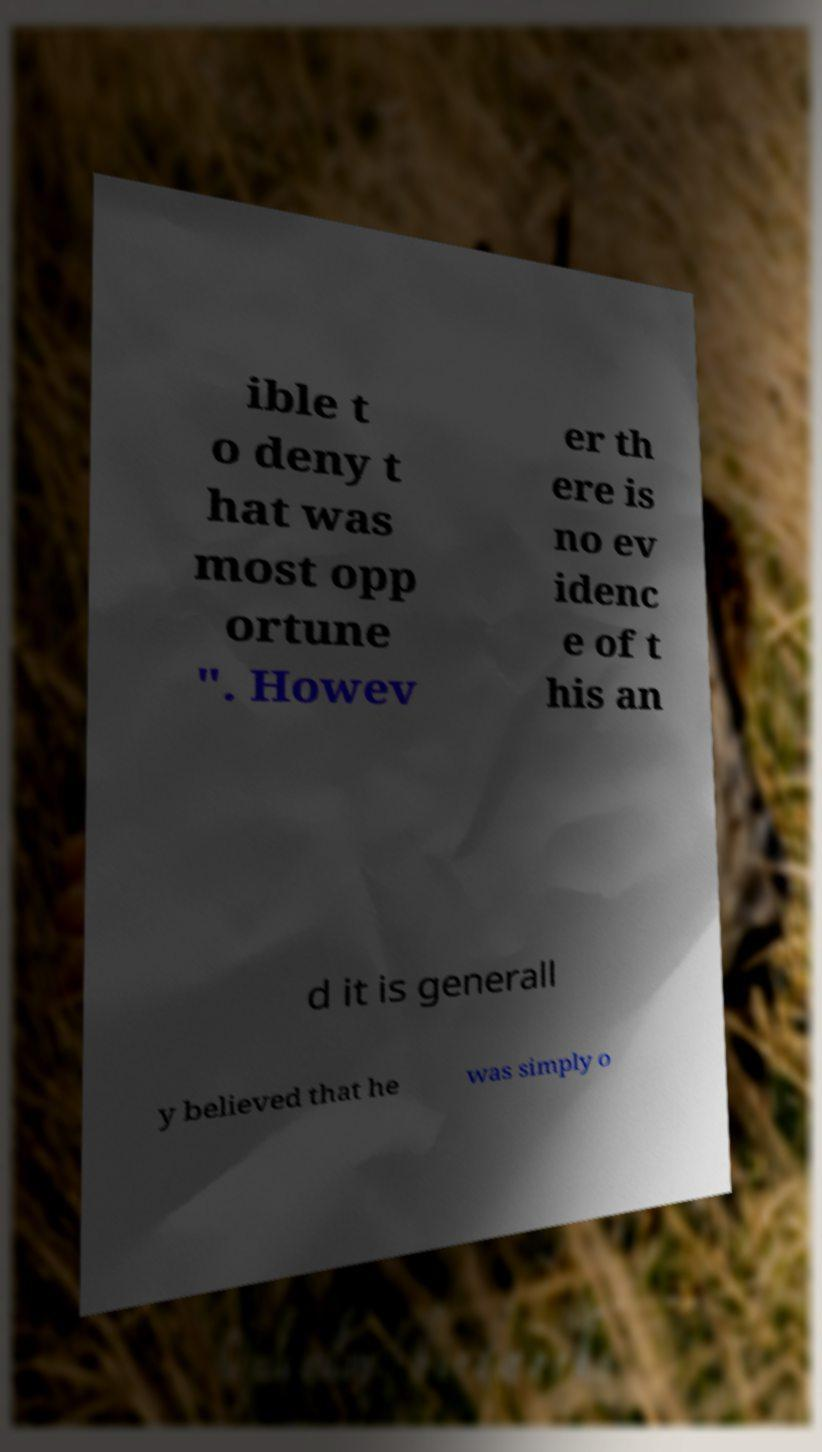Could you extract and type out the text from this image? ible t o deny t hat was most opp ortune ". Howev er th ere is no ev idenc e of t his an d it is generall y believed that he was simply o 